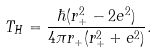<formula> <loc_0><loc_0><loc_500><loc_500>T _ { H } = \frac { \hbar { ( } r _ { + } ^ { 2 } - 2 e ^ { 2 } ) } { 4 \pi r _ { + } ( r _ { + } ^ { 2 } + e ^ { 2 } ) } .</formula> 